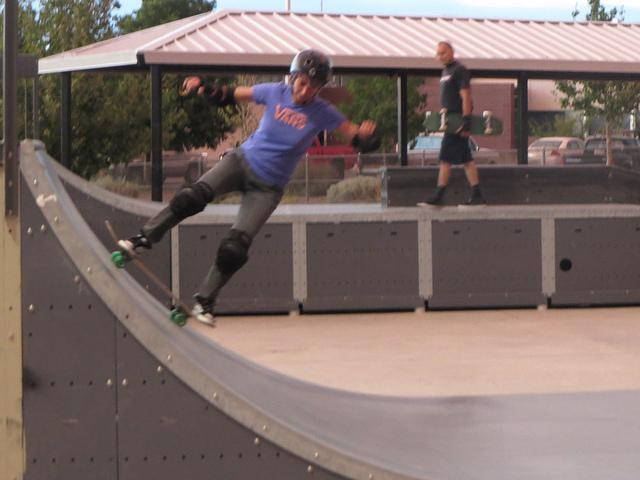On the front man what is most protected? Please explain your reasoning. knees. His knees are totally covered with protective pads. 